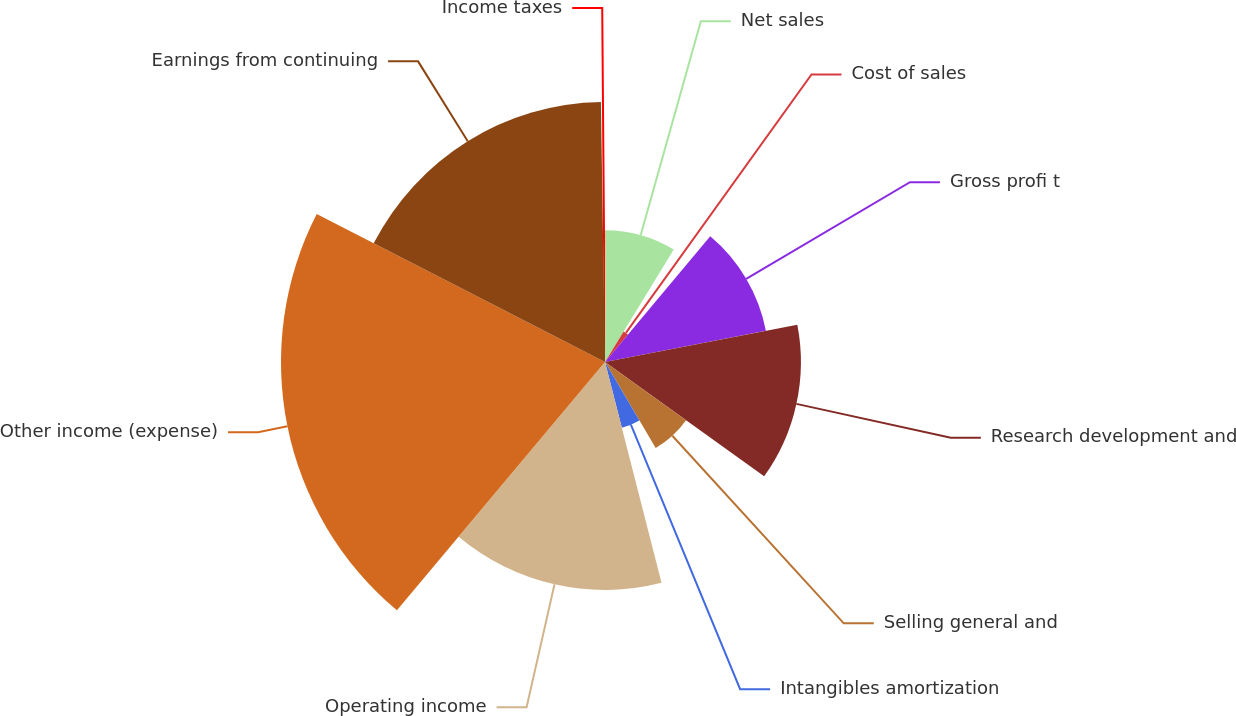Convert chart. <chart><loc_0><loc_0><loc_500><loc_500><pie_chart><fcel>Net sales<fcel>Cost of sales<fcel>Gross profi t<fcel>Research development and<fcel>Selling general and<fcel>Intangibles amortization<fcel>Operating income<fcel>Other income (expense)<fcel>Earnings from continuing<fcel>Income taxes<nl><fcel>8.73%<fcel>2.37%<fcel>10.85%<fcel>12.97%<fcel>6.61%<fcel>4.49%<fcel>15.09%<fcel>21.45%<fcel>17.21%<fcel>0.25%<nl></chart> 